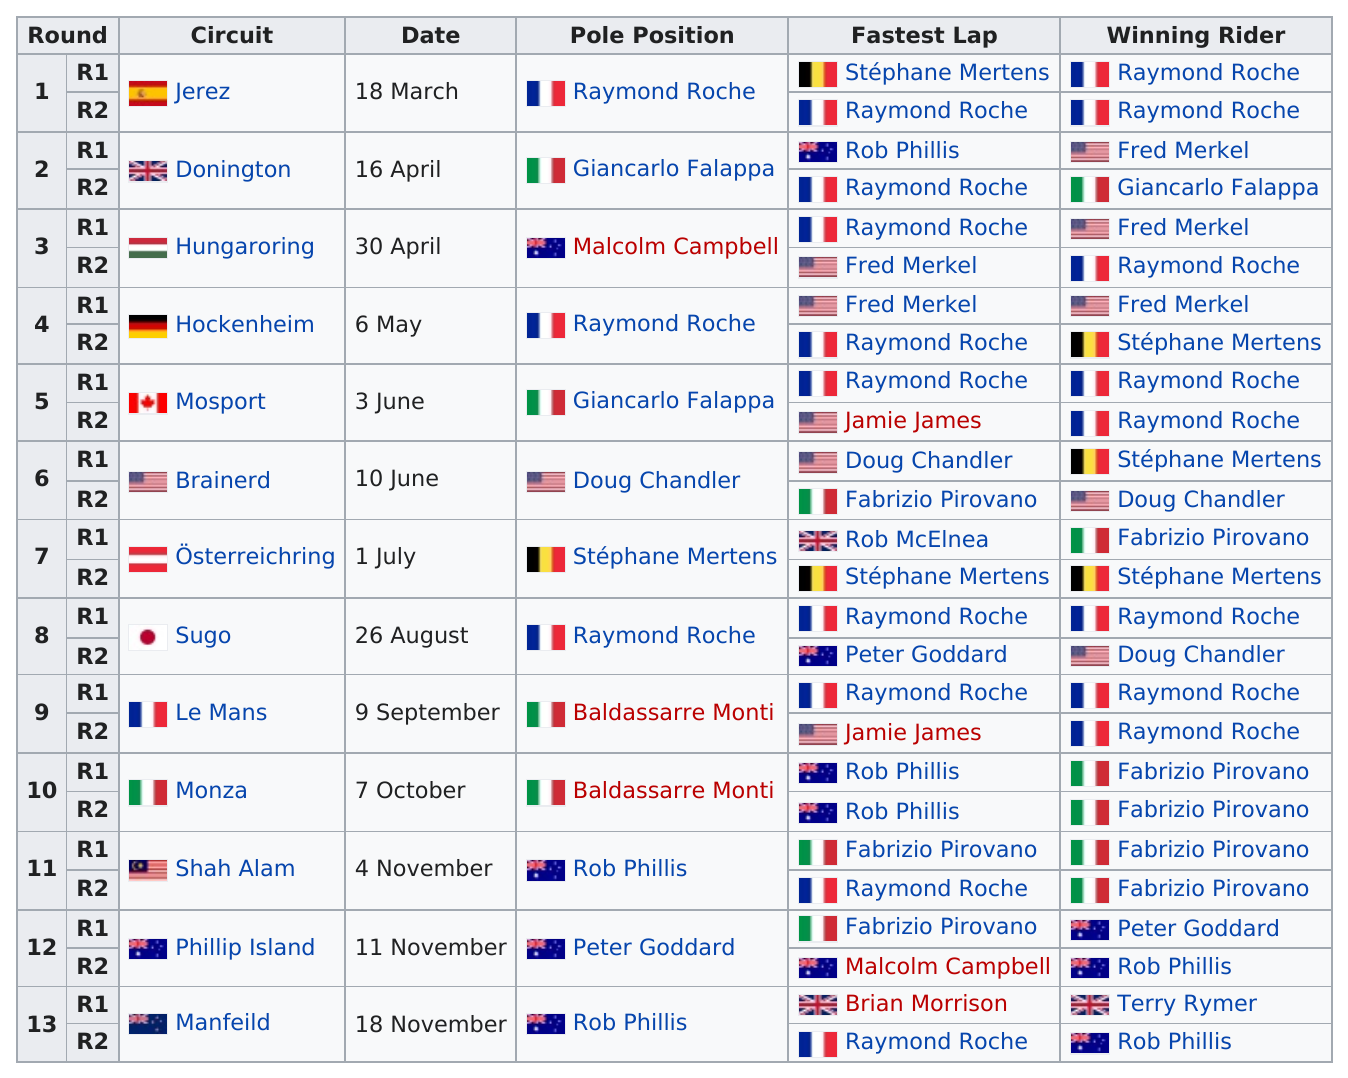Highlight a few significant elements in this photo. According to the information available, Raymond Roche won more rounds than Fabrizio Pirovano in their professional boxing careers. In June, the total number of circuits that took place was two. Jackie Stewart won the 1971 Hungarian Grand Prix at the Hungaroring circuit, and the next circuit he won at was the 1972 Dutch Grand Prix at Zandvoort, which was won by Raymond Roche. Giancarlo Falappa's name is listed before Doug Chandler's under the pole position column. The name of the first circuit is Jerez. 